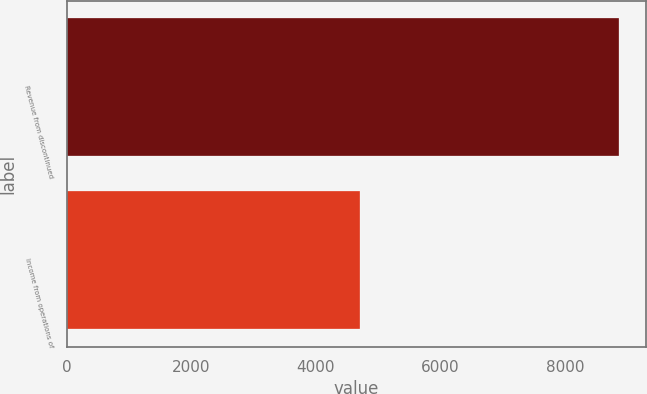<chart> <loc_0><loc_0><loc_500><loc_500><bar_chart><fcel>Revenue from discontinued<fcel>Income from operations of<nl><fcel>8859<fcel>4709<nl></chart> 